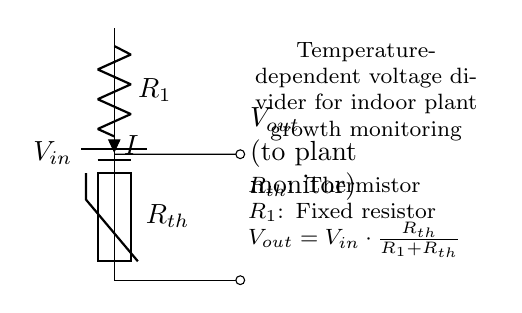What is the input voltage labeled as in the circuit? The input voltage is labeled as V_in, which is the voltage that supplies the circuit.
Answer: V_in What type of resistor is R_th? R_th is identified as a thermistor, which is a temperature-dependent resistor.
Answer: Thermistor What is V_out connected to? V_out is connected to the plant monitor, which uses this voltage to gauge the conditions for plant growth.
Answer: Plant monitor How does the voltage out vary with temperature? The voltage output V_out changes based on the resistance of the thermistor R_th, which varies with temperature, according to the voltage divider equation.
Answer: V_out changes with temperature What is the role of the fixed resistor R_1? R_1 serves as a fixed reference resistance in the voltage divider circuit, determining how V_out relates to R_th.
Answer: Reference resistance Why is this circuit considered a voltage divider? This circuit is a voltage divider because it divides the input voltage, creating a lower output voltage based on the resistances R_1 and R_th combined.
Answer: Divides input voltage What formula is used to calculate V_out? The formula is V_out = V_in * (R_th / (R_1 + R_th)), which gives the relationship between input voltage and output voltage based on the resistances.
Answer: V_out = V_in * (R_th / (R_1 + R_th)) 